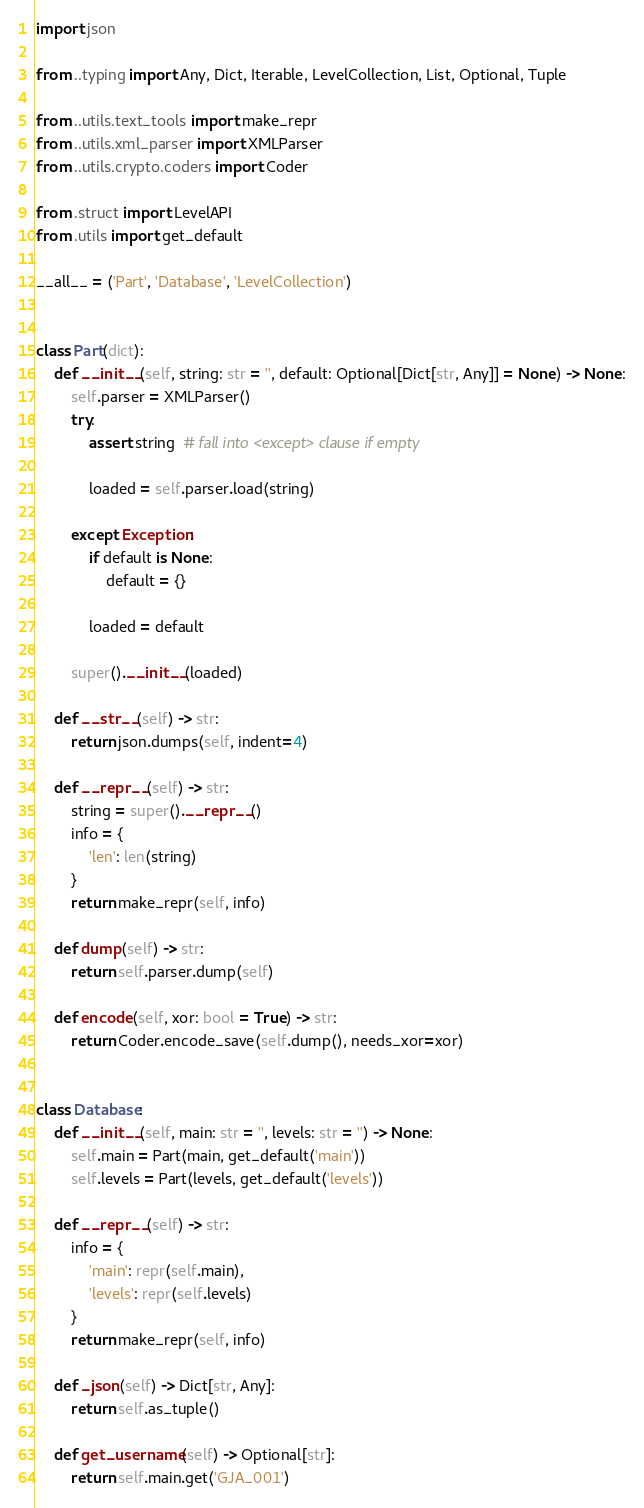Convert code to text. <code><loc_0><loc_0><loc_500><loc_500><_Python_>import json

from ..typing import Any, Dict, Iterable, LevelCollection, List, Optional, Tuple

from ..utils.text_tools import make_repr
from ..utils.xml_parser import XMLParser
from ..utils.crypto.coders import Coder

from .struct import LevelAPI
from .utils import get_default

__all__ = ('Part', 'Database', 'LevelCollection')


class Part(dict):
    def __init__(self, string: str = '', default: Optional[Dict[str, Any]] = None) -> None:
        self.parser = XMLParser()
        try:
            assert string  # fall into <except> clause if empty

            loaded = self.parser.load(string)

        except Exception:
            if default is None:
                default = {}

            loaded = default

        super().__init__(loaded)

    def __str__(self) -> str:
        return json.dumps(self, indent=4)

    def __repr__(self) -> str:
        string = super().__repr__()
        info = {
            'len': len(string)
        }
        return make_repr(self, info)

    def dump(self) -> str:
        return self.parser.dump(self)

    def encode(self, xor: bool = True) -> str:
        return Coder.encode_save(self.dump(), needs_xor=xor)


class Database:
    def __init__(self, main: str = '', levels: str = '') -> None:
        self.main = Part(main, get_default('main'))
        self.levels = Part(levels, get_default('levels'))

    def __repr__(self) -> str:
        info = {
            'main': repr(self.main),
            'levels': repr(self.levels)
        }
        return make_repr(self, info)

    def _json(self) -> Dict[str, Any]:
        return self.as_tuple()

    def get_username(self) -> Optional[str]:
        return self.main.get('GJA_001')
</code> 